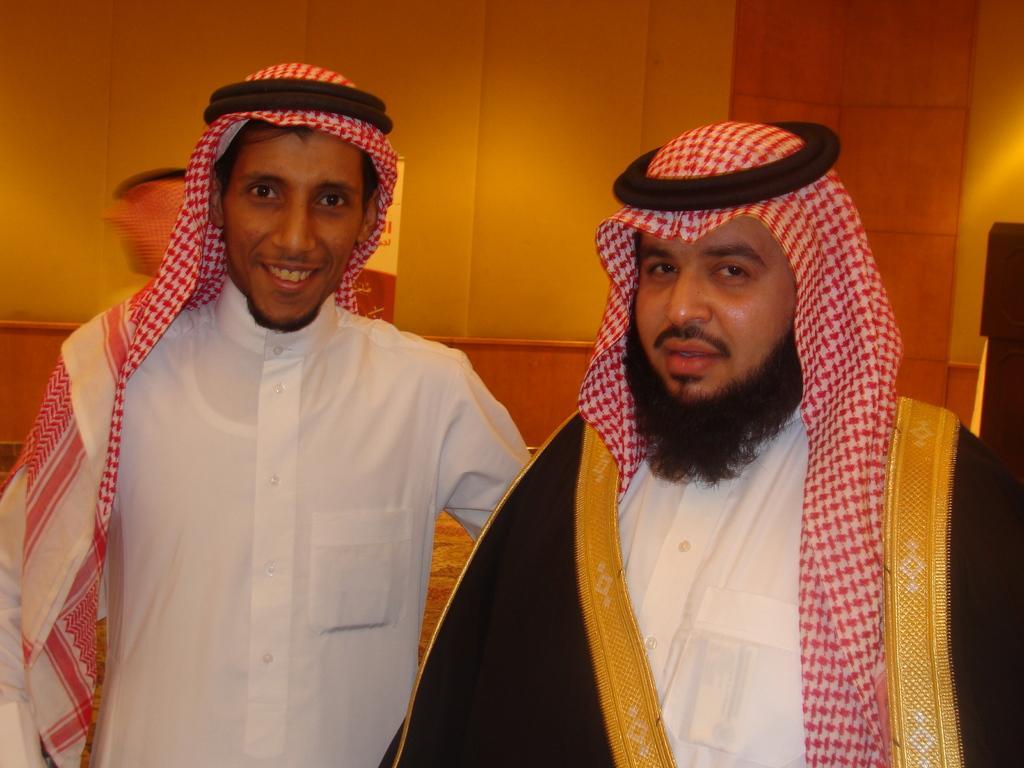In one or two sentences, can you explain what this image depicts? In this image in front there are two persons. Behind them there is a wall. 